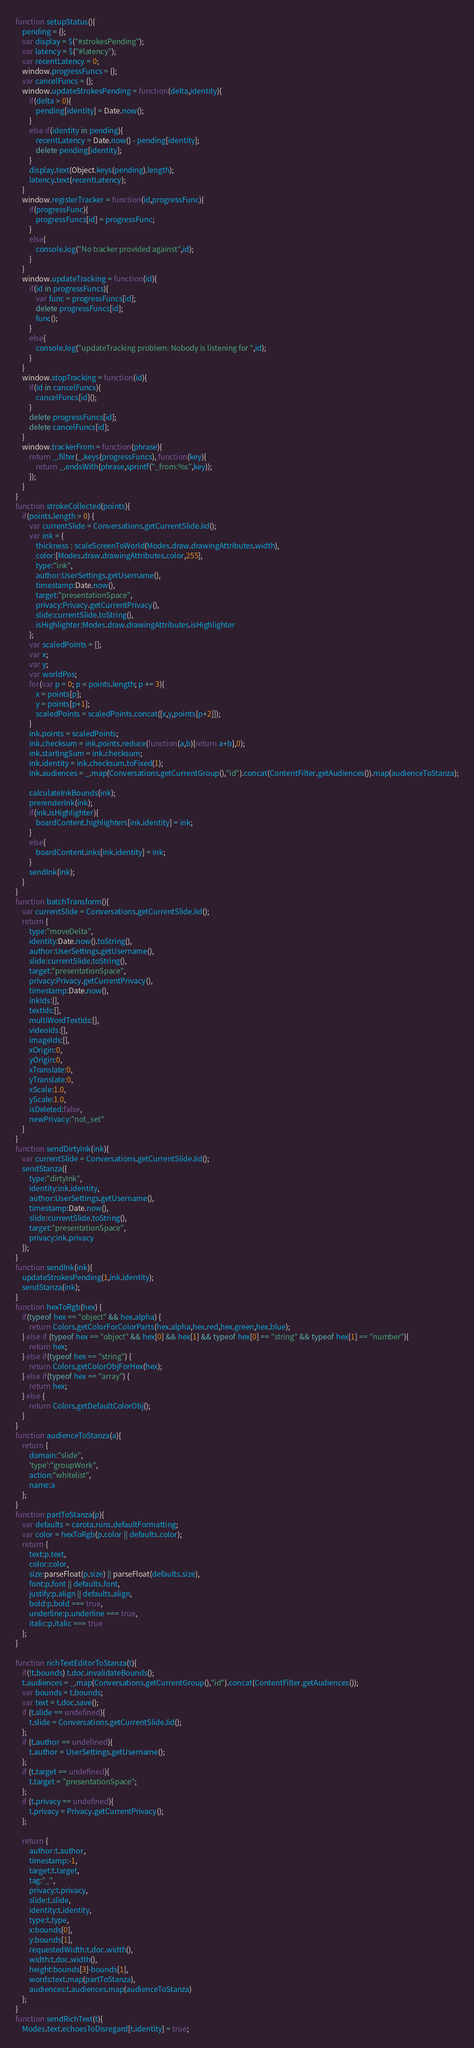<code> <loc_0><loc_0><loc_500><loc_500><_JavaScript_>function setupStatus(){
    pending = {};
    var display = $("#strokesPending");
    var latency = $("#latency");
    var recentLatency = 0;
    window.progressFuncs = {};
    var cancelFuncs = {};
    window.updateStrokesPending = function(delta,identity){
        if(delta > 0){
            pending[identity] = Date.now();
        }
        else if(identity in pending){
            recentLatency = Date.now() - pending[identity];
            delete pending[identity];
        }
        display.text(Object.keys(pending).length);
        latency.text(recentLatency);
    }
    window.registerTracker = function(id,progressFunc){
        if(progressFunc){
            progressFuncs[id] = progressFunc;
        }
        else{
            console.log("No tracker provided against",id);
        }
    }
    window.updateTracking = function(id){
        if(id in progressFuncs){
            var func = progressFuncs[id];
            delete progressFuncs[id];
            func();
        }
        else{
            console.log("updateTracking problem: Nobody is listening for ",id);
        }
    }
    window.stopTracking = function(id){
        if(id in cancelFuncs){
            cancelFuncs[id]();
        }
        delete progressFuncs[id];
        delete cancelFuncs[id];
    }
    window.trackerFrom = function(phrase){
        return _.filter(_.keys(progressFuncs), function(key){
            return _.endsWith(phrase,sprintf("_from:%s",key));
        });
    }
}
function strokeCollected(points){
    if(points.length > 0) {
        var currentSlide = Conversations.getCurrentSlideJid();
        var ink = {
            thickness : scaleScreenToWorld(Modes.draw.drawingAttributes.width),
            color:[Modes.draw.drawingAttributes.color,255],
            type:"ink",
            author:UserSettings.getUsername(),
            timestamp:Date.now(),
            target:"presentationSpace",
            privacy:Privacy.getCurrentPrivacy(),
            slide:currentSlide.toString(),
            isHighlighter:Modes.draw.drawingAttributes.isHighlighter
        };
        var scaledPoints = [];
        var x;
        var y;
        var worldPos;
        for(var p = 0; p < points.length; p += 3){
            x = points[p];
            y = points[p+1];
            scaledPoints = scaledPoints.concat([x,y,points[p+2]]);
        }
        ink.points = scaledPoints;
        ink.checksum = ink.points.reduce(function(a,b){return a+b},0);
        ink.startingSum = ink.checksum;
        ink.identity = ink.checksum.toFixed(1);
        ink.audiences = _.map(Conversations.getCurrentGroup(),"id").concat(ContentFilter.getAudiences()).map(audienceToStanza);

        calculateInkBounds(ink);
        prerenderInk(ink);
        if(ink.isHighlighter){
            boardContent.highlighters[ink.identity] = ink;
        }
        else{
            boardContent.inks[ink.identity] = ink;
        }
        sendInk(ink);
    }
}
function batchTransform(){
    var currentSlide = Conversations.getCurrentSlideJid();
    return {
        type:"moveDelta",
        identity:Date.now().toString(),
        author:UserSettings.getUsername(),
        slide:currentSlide.toString(),
        target:"presentationSpace",
        privacy:Privacy.getCurrentPrivacy(),
        timestamp:Date.now(),
        inkIds:[],
        textIds:[],
        multiWordTextIds:[],
        videoIds:[],
        imageIds:[],
        xOrigin:0,
        yOrigin:0,
        xTranslate:0,
        yTranslate:0,
        xScale:1.0,
        yScale:1.0,
        isDeleted:false,
        newPrivacy:"not_set"
    }
}
function sendDirtyInk(ink){
    var currentSlide = Conversations.getCurrentSlideJid();
    sendStanza({
        type:"dirtyInk",
        identity:ink.identity,
        author:UserSettings.getUsername(),
        timestamp:Date.now(),
        slide:currentSlide.toString(),
        target:"presentationSpace",
        privacy:ink.privacy
    });
}
function sendInk(ink){
    updateStrokesPending(1,ink.identity);
    sendStanza(ink);
}
function hexToRgb(hex) {
    if(typeof hex == "object" && hex.alpha) {
        return Colors.getColorForColorParts(hex.alpha,hex.red,hex.green,hex.blue);
    } else if (typeof hex == "object" && hex[0] && hex[1] && typeof hex[0] == "string" && typeof hex[1] == "number"){
        return hex;
    } else if(typeof hex == "string") {
        return Colors.getColorObjForHex(hex);
    } else if(typeof hex == "array") {
        return hex;
    } else {
        return Colors.getDefaultColorObj();
    }
}
function audienceToStanza(a){
    return {
        domain:"slide",
        'type':"groupWork",
        action:"whitelist",
        name:a
    };
}
function partToStanza(p){
    var defaults = carota.runs.defaultFormatting;
    var color = hexToRgb(p.color || defaults.color);
    return {
        text:p.text,
        color:color,
        size:parseFloat(p.size) || parseFloat(defaults.size),
        font:p.font || defaults.font,
        justify:p.align || defaults.align,
        bold:p.bold === true,
        underline:p.underline === true,
        italic:p.italic === true
    };
}

function richTextEditorToStanza(t){
    if(!t.bounds) t.doc.invalidateBounds();
    t.audiences = _.map(Conversations.getCurrentGroup(),"id").concat(ContentFilter.getAudiences());
    var bounds = t.bounds;
    var text = t.doc.save();
    if (t.slide == undefined){
        t.slide = Conversations.getCurrentSlideJid();
    };
    if (t.author == undefined){
        t.author = UserSettings.getUsername();
    };
    if (t.target == undefined){
        t.target = "presentationSpace";
    };
    if (t.privacy == undefined){
        t.privacy = Privacy.getCurrentPrivacy();
    };

    return {
        author:t.author,
        timestamp:-1,
        target:t.target,
        tag:"_",
        privacy:t.privacy,
        slide:t.slide,
        identity:t.identity,
        type:t.type,
        x:bounds[0],
        y:bounds[1],
        requestedWidth:t.doc.width(),
        width:t.doc.width(),
        height:bounds[3]-bounds[1],
        words:text.map(partToStanza),
        audiences:t.audiences.map(audienceToStanza)
    };
}
function sendRichText(t){
    Modes.text.echoesToDisregard[t.identity] = true;</code> 